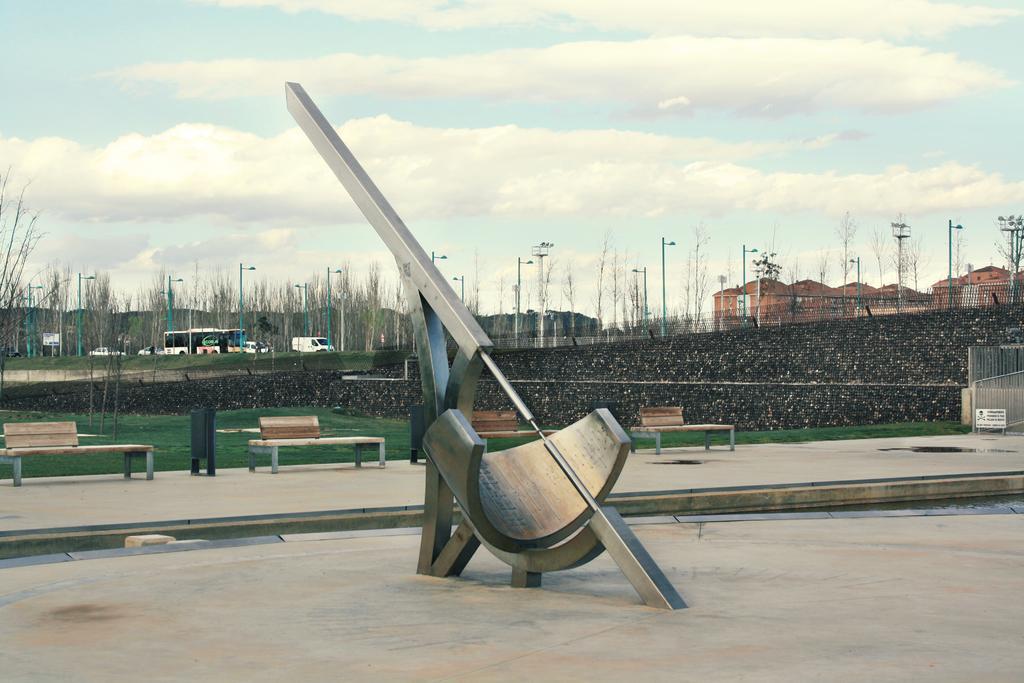Describe this image in one or two sentences. In this image, we can see a sculpture in front of benches. There are vehicles and some poles in the middle of the image. There is a building on the right side of the image. In the background of image, there is a sky. 